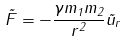Convert formula to latex. <formula><loc_0><loc_0><loc_500><loc_500>\vec { F } = - \frac { \gamma m _ { 1 } m _ { 2 } } { r ^ { 2 } } \vec { u } _ { r }</formula> 